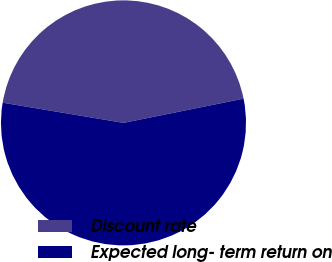Convert chart to OTSL. <chart><loc_0><loc_0><loc_500><loc_500><pie_chart><fcel>Discount rate<fcel>Expected long- term return on<nl><fcel>44.2%<fcel>55.8%<nl></chart> 